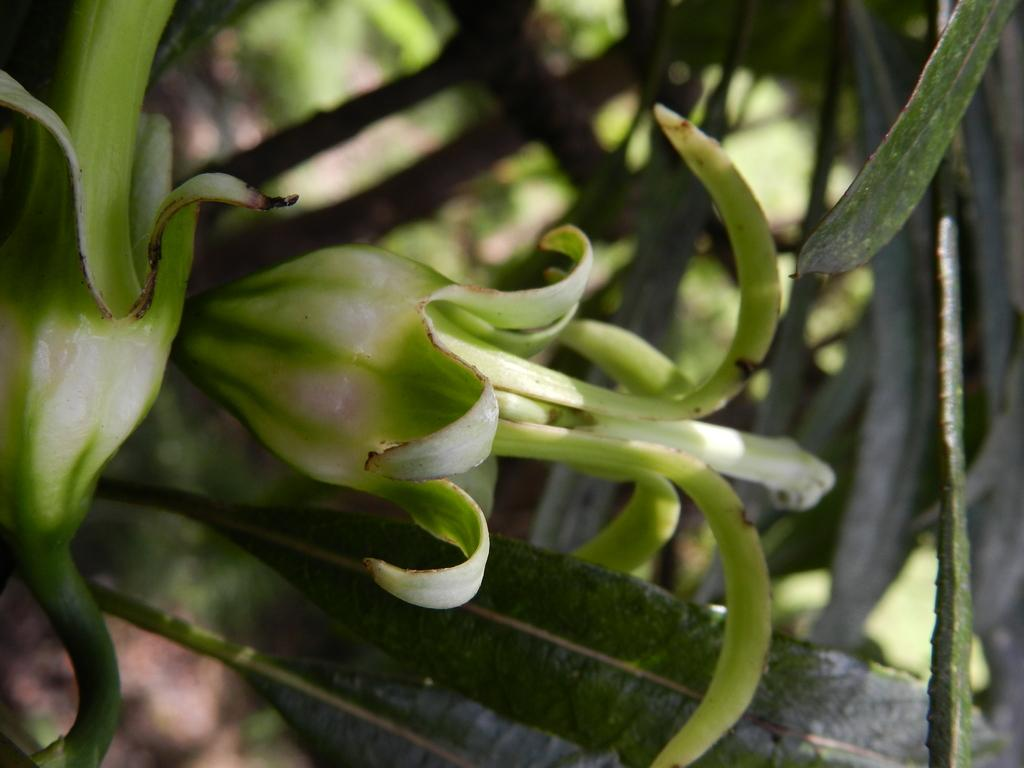What is present in the image? There are flowers in the image. What are the flowers situated on? The flowers are on plants. What colors can be seen in the flowers? The flowers are in white and green colors. Can you describe the background of the image? The background of the image is blurred. How are the plants playing with the hook in the image? There is no hook present in the image, and the plants are not playing with anything. 